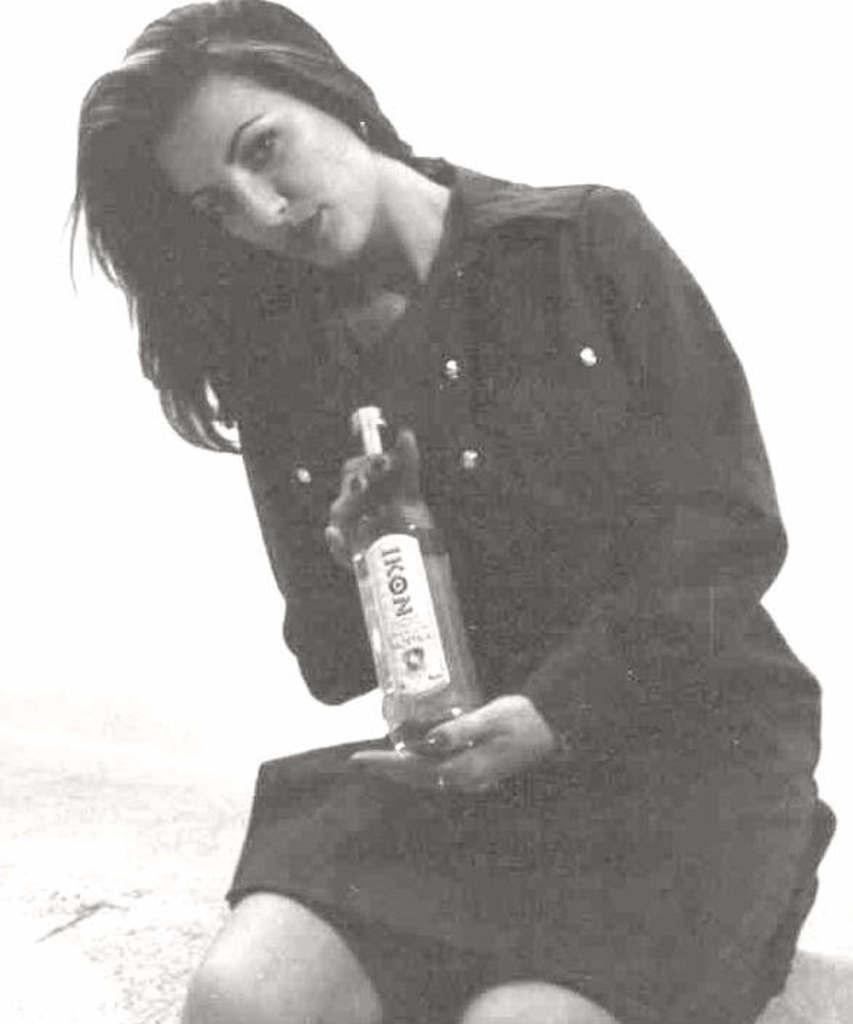What is the color scheme of the image? The image is black and white. What is the woman in the image doing? The woman is sitting in the image. What is the woman holding in the image? The woman is holding a bottle in the image. What is written on the bottle? The bottle has the name "icon" on it. What type of pot is visible in the image? There is no pot present in the image. Can you tell me how many cars are in the image? There are no cars present in the image. 